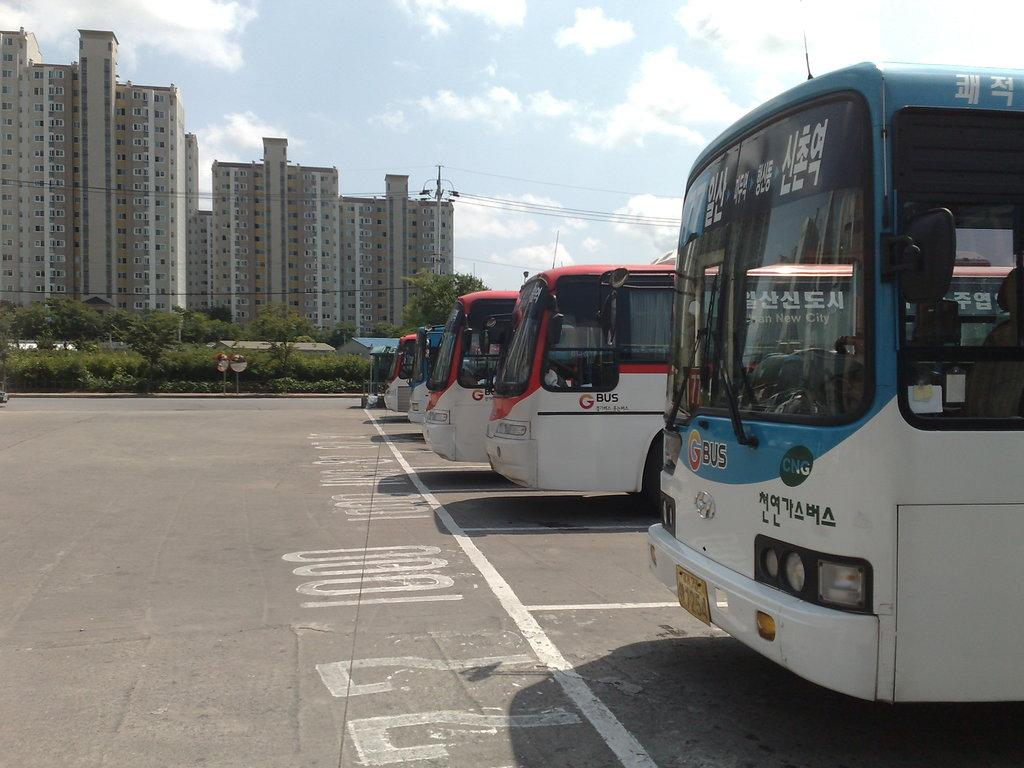<image>
Write a terse but informative summary of the picture. 1000 is painted on the front of this empty parking spot for buses. 